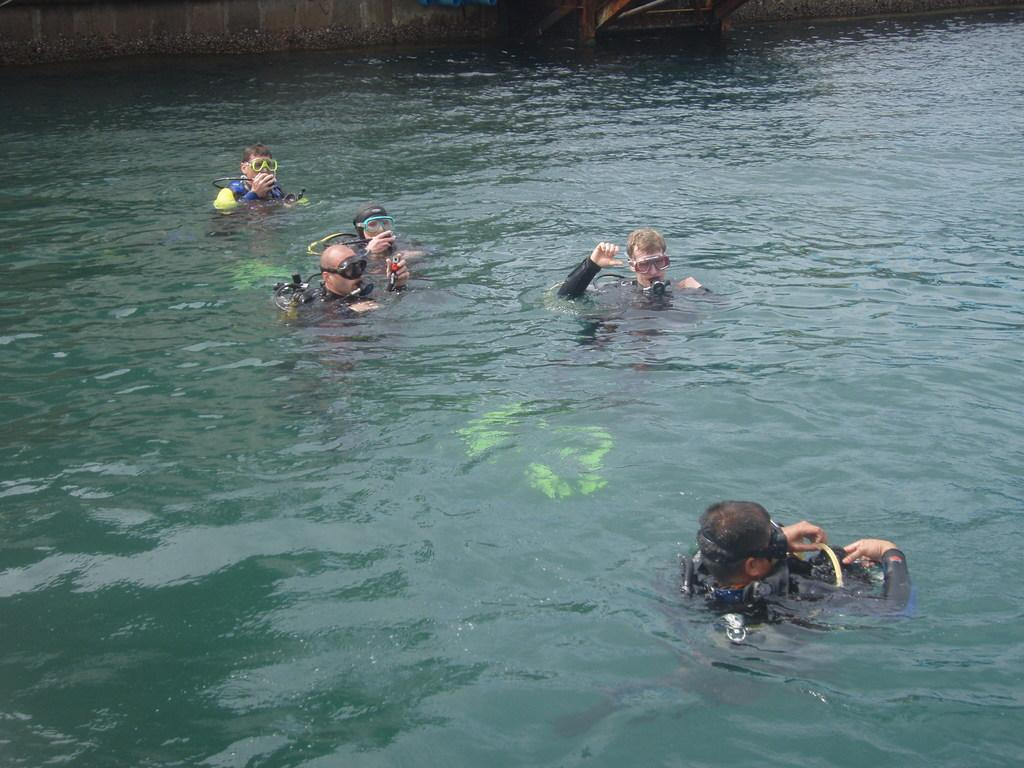How many people are in the image? There is a group of people in the image. What are the people doing in the image? The people are in the water. What equipment are the people using in the water? The people are using oxygen cylinders. What color are the swimming costumes worn by the people in the image? The people are wearing black swimming costumes. What type of picture is hanging on the wall near the people in the image? There is no mention of a picture hanging on the wall near the people in the image. Can you tell me what request the people in the image are making? There is no indication of a request being made by the people in the image. Are there any bricks visible in the image? There is no mention of bricks in the image. 